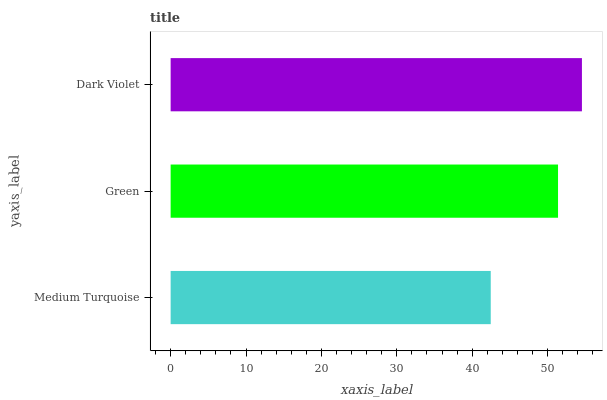Is Medium Turquoise the minimum?
Answer yes or no. Yes. Is Dark Violet the maximum?
Answer yes or no. Yes. Is Green the minimum?
Answer yes or no. No. Is Green the maximum?
Answer yes or no. No. Is Green greater than Medium Turquoise?
Answer yes or no. Yes. Is Medium Turquoise less than Green?
Answer yes or no. Yes. Is Medium Turquoise greater than Green?
Answer yes or no. No. Is Green less than Medium Turquoise?
Answer yes or no. No. Is Green the high median?
Answer yes or no. Yes. Is Green the low median?
Answer yes or no. Yes. Is Medium Turquoise the high median?
Answer yes or no. No. Is Dark Violet the low median?
Answer yes or no. No. 